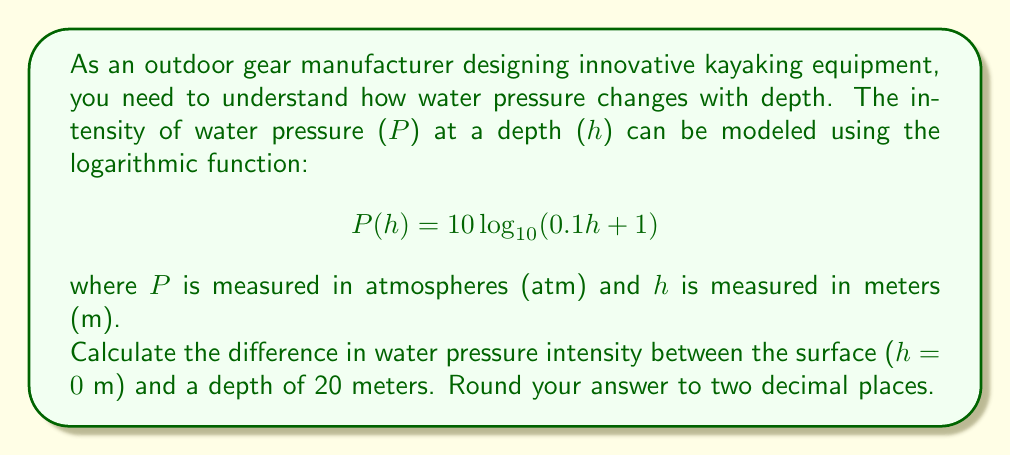Provide a solution to this math problem. To solve this problem, we need to calculate the water pressure at two depths: the surface (h = 0 m) and 20 meters deep (h = 20 m). Then, we'll find the difference between these two values.

1. Calculate pressure at the surface (h = 0 m):
   $$ P(0) = 10 \log_{10}(0.1 \cdot 0 + 1) = 10 \log_{10}(1) = 10 \cdot 0 = 0 \text{ atm} $$

2. Calculate pressure at 20 meters depth:
   $$ P(20) = 10 \log_{10}(0.1 \cdot 20 + 1) = 10 \log_{10}(3) $$
   
   Using a calculator or logarithm table:
   $$ P(20) = 10 \cdot 0.47712125472 = 4.7712125472 \text{ atm} $$

3. Calculate the difference in pressure:
   $$ \Delta P = P(20) - P(0) = 4.7712125472 - 0 = 4.7712125472 \text{ atm} $$

4. Round the result to two decimal places:
   $$ \Delta P \approx 4.77 \text{ atm} $$

This result shows that the water pressure increases by approximately 4.77 atmospheres when descending from the surface to a depth of 20 meters. This information is crucial for designing kayaking equipment that can withstand varying water pressures at different depths.
Answer: $4.77 \text{ atm}$ 